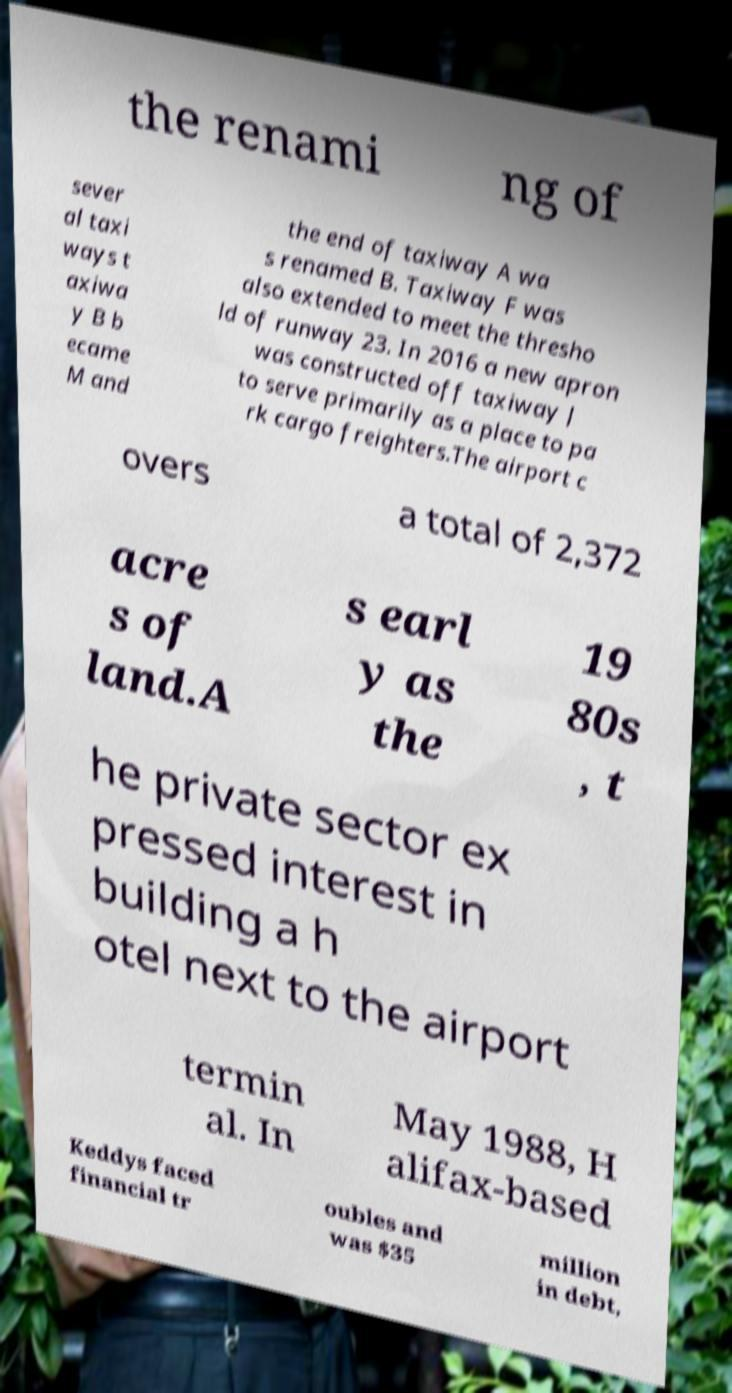Can you accurately transcribe the text from the provided image for me? the renami ng of sever al taxi ways t axiwa y B b ecame M and the end of taxiway A wa s renamed B. Taxiway F was also extended to meet the thresho ld of runway 23. In 2016 a new apron was constructed off taxiway J to serve primarily as a place to pa rk cargo freighters.The airport c overs a total of 2,372 acre s of land.A s earl y as the 19 80s , t he private sector ex pressed interest in building a h otel next to the airport termin al. In May 1988, H alifax-based Keddys faced financial tr oubles and was $35 million in debt, 